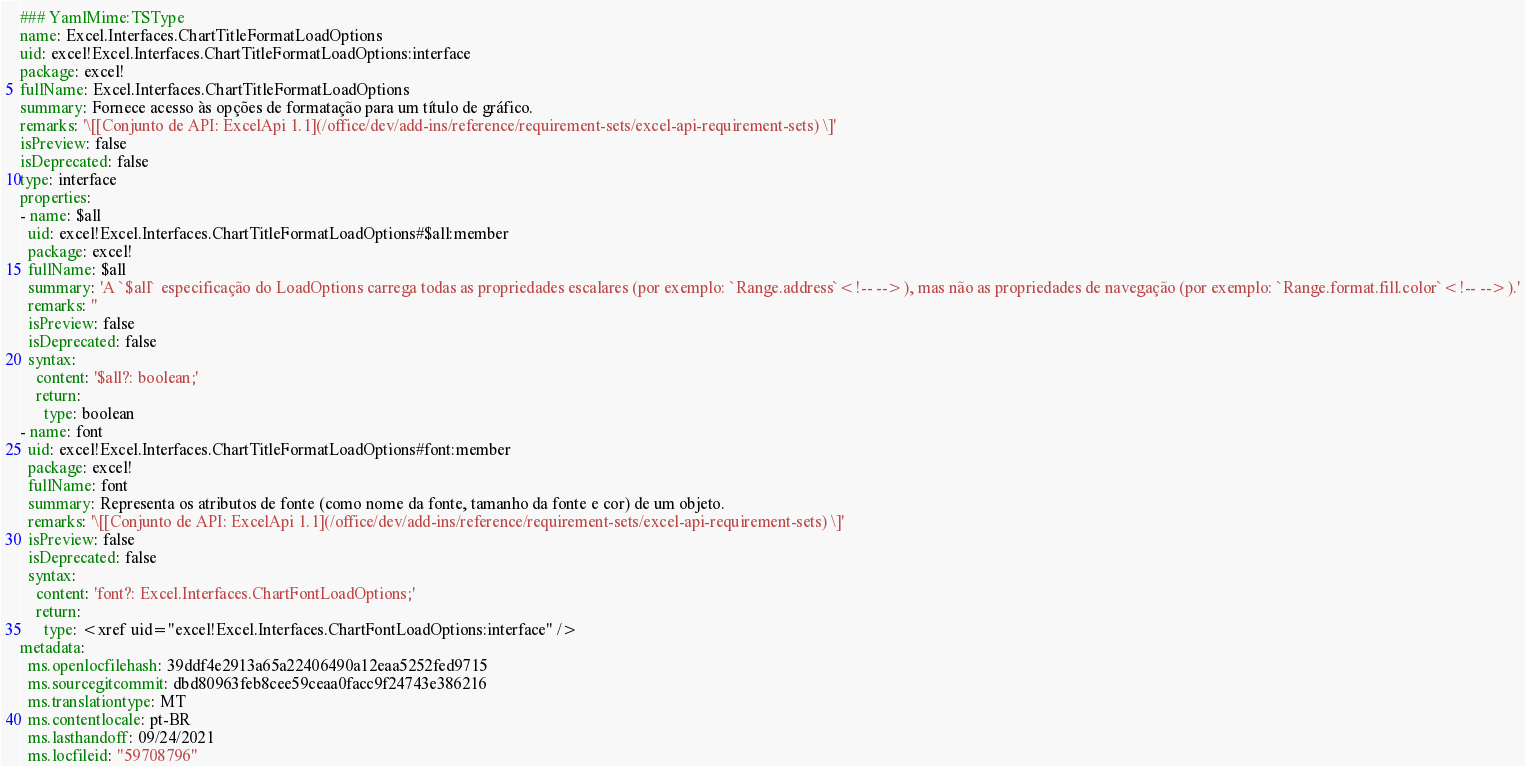Convert code to text. <code><loc_0><loc_0><loc_500><loc_500><_YAML_>### YamlMime:TSType
name: Excel.Interfaces.ChartTitleFormatLoadOptions
uid: excel!Excel.Interfaces.ChartTitleFormatLoadOptions:interface
package: excel!
fullName: Excel.Interfaces.ChartTitleFormatLoadOptions
summary: Fornece acesso às opções de formatação para um título de gráfico.
remarks: '\[[Conjunto de API: ExcelApi 1.1](/office/dev/add-ins/reference/requirement-sets/excel-api-requirement-sets) \]'
isPreview: false
isDeprecated: false
type: interface
properties:
- name: $all
  uid: excel!Excel.Interfaces.ChartTitleFormatLoadOptions#$all:member
  package: excel!
  fullName: $all
  summary: 'A `$all` especificação do LoadOptions carrega todas as propriedades escalares (por exemplo: `Range.address`<!-- -->), mas não as propriedades de navegação (por exemplo: `Range.format.fill.color`<!-- -->).'
  remarks: ''
  isPreview: false
  isDeprecated: false
  syntax:
    content: '$all?: boolean;'
    return:
      type: boolean
- name: font
  uid: excel!Excel.Interfaces.ChartTitleFormatLoadOptions#font:member
  package: excel!
  fullName: font
  summary: Representa os atributos de fonte (como nome da fonte, tamanho da fonte e cor) de um objeto.
  remarks: '\[[Conjunto de API: ExcelApi 1.1](/office/dev/add-ins/reference/requirement-sets/excel-api-requirement-sets) \]'
  isPreview: false
  isDeprecated: false
  syntax:
    content: 'font?: Excel.Interfaces.ChartFontLoadOptions;'
    return:
      type: <xref uid="excel!Excel.Interfaces.ChartFontLoadOptions:interface" />
metadata:
  ms.openlocfilehash: 39ddf4e2913a65a22406490a12eaa5252fed9715
  ms.sourcegitcommit: dbd80963feb8cee59ceaa0facc9f24743e386216
  ms.translationtype: MT
  ms.contentlocale: pt-BR
  ms.lasthandoff: 09/24/2021
  ms.locfileid: "59708796"
</code> 